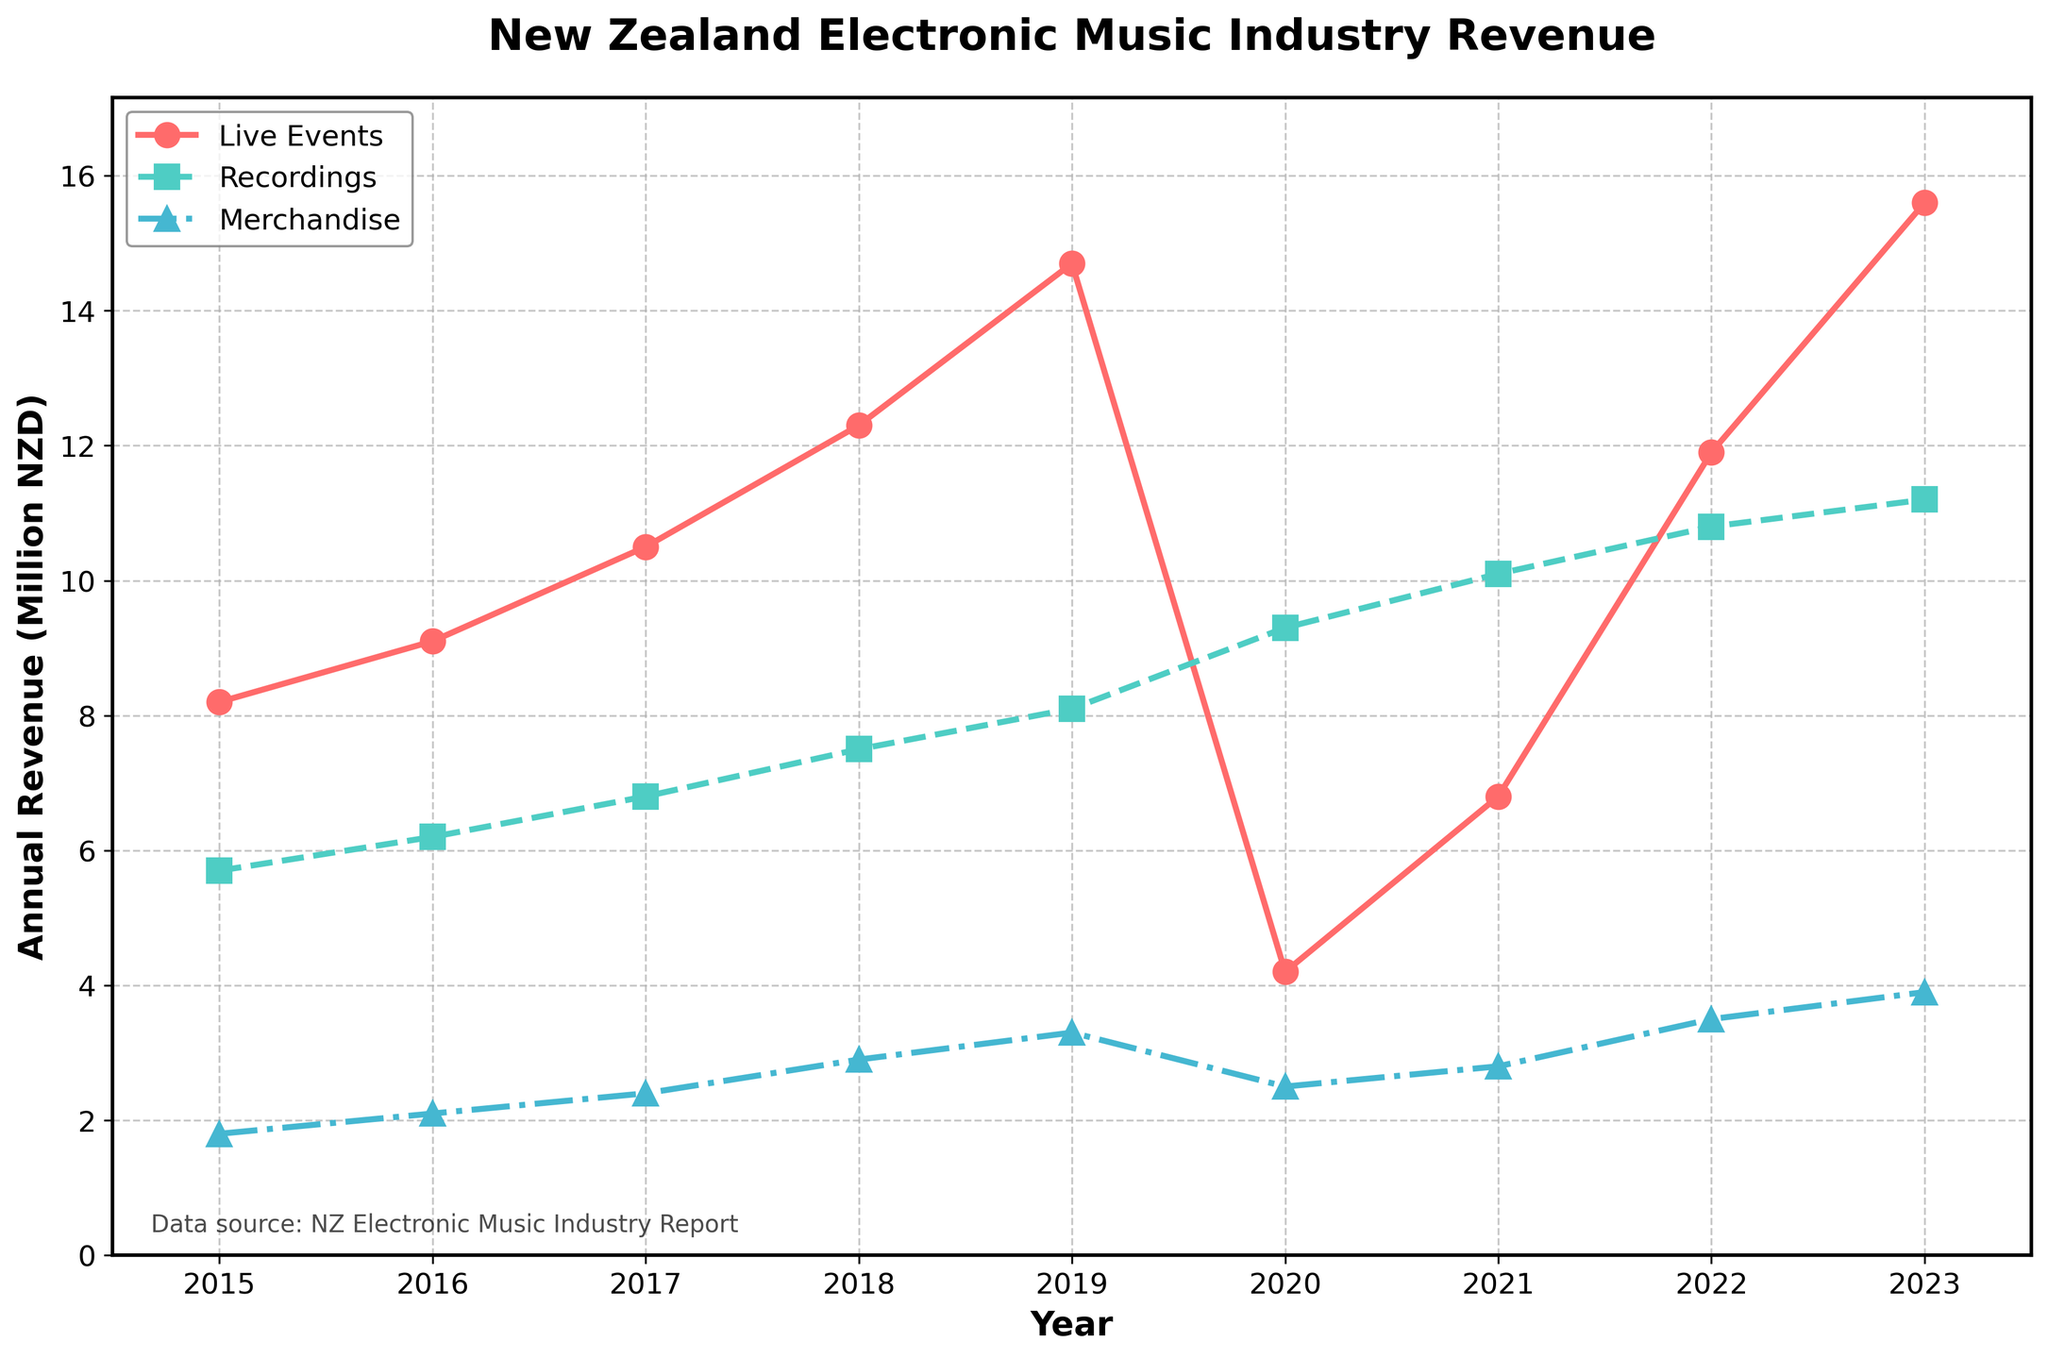What's the difference between the revenue generated by live events and recordings in 2019? The revenue from live events in 2019 is 14.7 million NZD, and from recordings is 8.1 million NZD. Subtract 8.1 from 14.7: 14.7 - 8.1 = 6.6 million NZD.
Answer: 6.6 million NZD In which year did merchandise revenue first exceed 3 million NZD? Examine the merchandise revenue data. The data shows it first exceeds 3 million NZD in the year 2019.
Answer: 2019 How did the revenue from live events change between 2019 and 2020? From the data, the revenue from live events in 2019 is 14.7 million NZD and in 2020 is 4.2 million NZD. Calculate the change: 4.2 - 14.7 = -10.5 million NZD.
Answer: Decreased by 10.5 million NZD Which category had the highest revenue in 2021? Compare the revenues for live events, recordings, and merchandise in 2021. Recordings had the highest revenue at 10.1 million NZD.
Answer: Recordings What is the total revenue across all categories for the year 2022? Sum the revenues from live events, recordings, and merchandise for 2022: 11.9 + 10.8 + 3.5 = 26.2 million NZD.
Answer: 26.2 million NZD Which category shows the most steady increase over the years? Examine the trends of live events, recordings, and merchandise from 2015 to 2023. Recordings show the most steady increase, with revenue rising consistently each year.
Answer: Recordings By how much did the revenue from recordings increase from 2015 to 2023? The revenue from recordings in 2015 is 5.7 million NZD and in 2023 it is 11.2 million NZD. Calculate the increase: 11.2 - 5.7 = 5.5 million NZD.
Answer: 5.5 million NZD In which year did live events revenue drop to its lowest, and how much was it? From the data, the lowest live events revenue is in 2020 at 4.2 million NZD.
Answer: 2020, 4.2 million NZD 